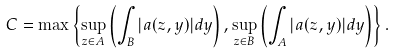Convert formula to latex. <formula><loc_0><loc_0><loc_500><loc_500>C = \max \left \{ \sup _ { z \in A } \left ( \int _ { B } | a ( z , y ) | d y \right ) , \sup _ { z \in B } \left ( \int _ { A } | a ( z , y ) | d y \right ) \right \} .</formula> 